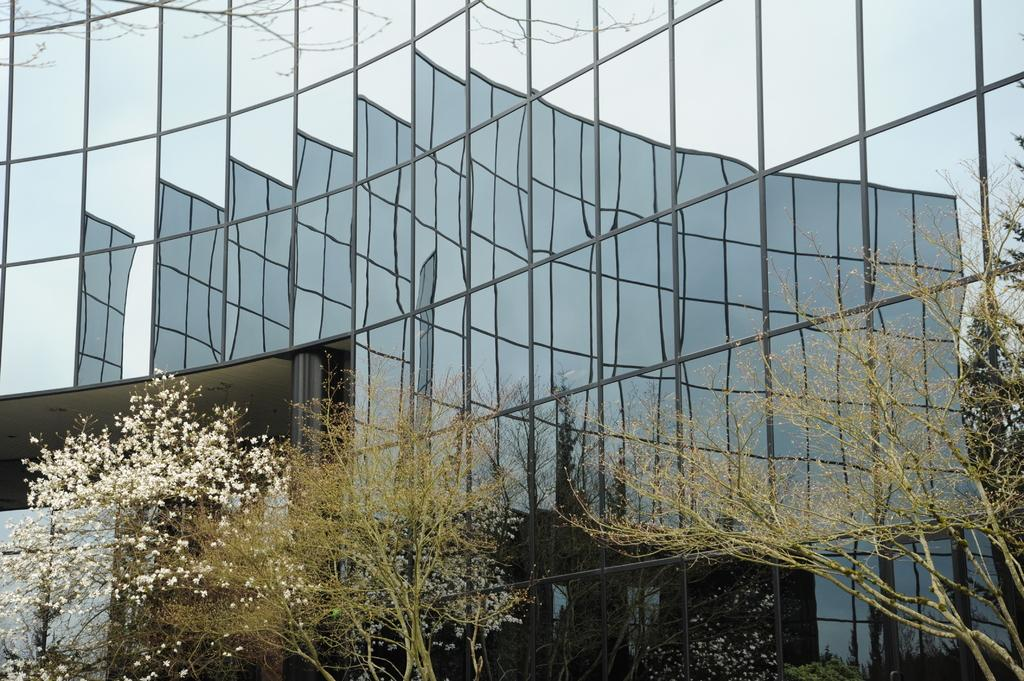What type of wall is visible in the image? There is a framed glass wall in the image. What can be seen through the glass wall? Trees are visible through the glass wall. What structure is present in the image? There is a building in the image. What is visible in the background of the image? The sky is visible in the image. Where are the children playing with their magic trousers in the image? There are no children or magic trousers present in the image. 